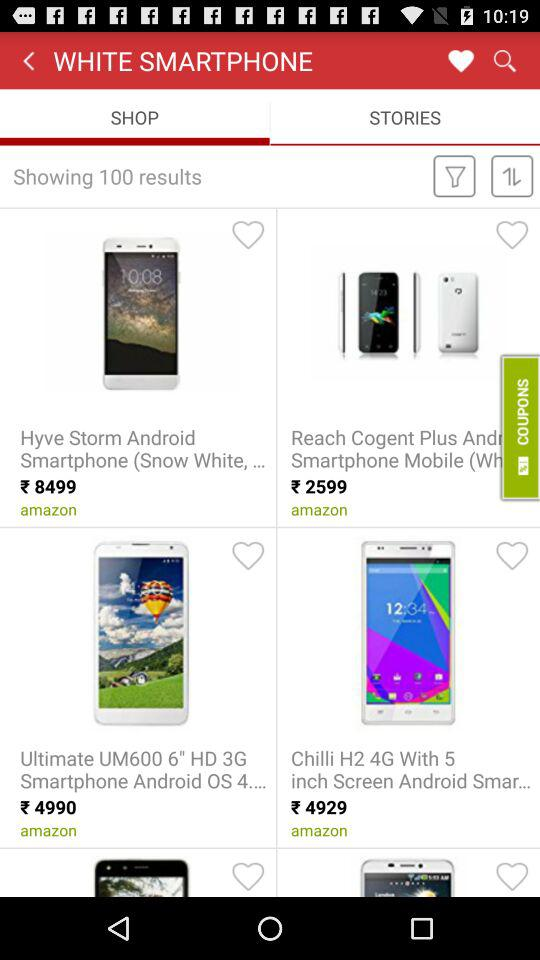What is the price of the Hyve Storm Android smartphone? The price of the Hyve Storm Android smartphone is ₹8499. 